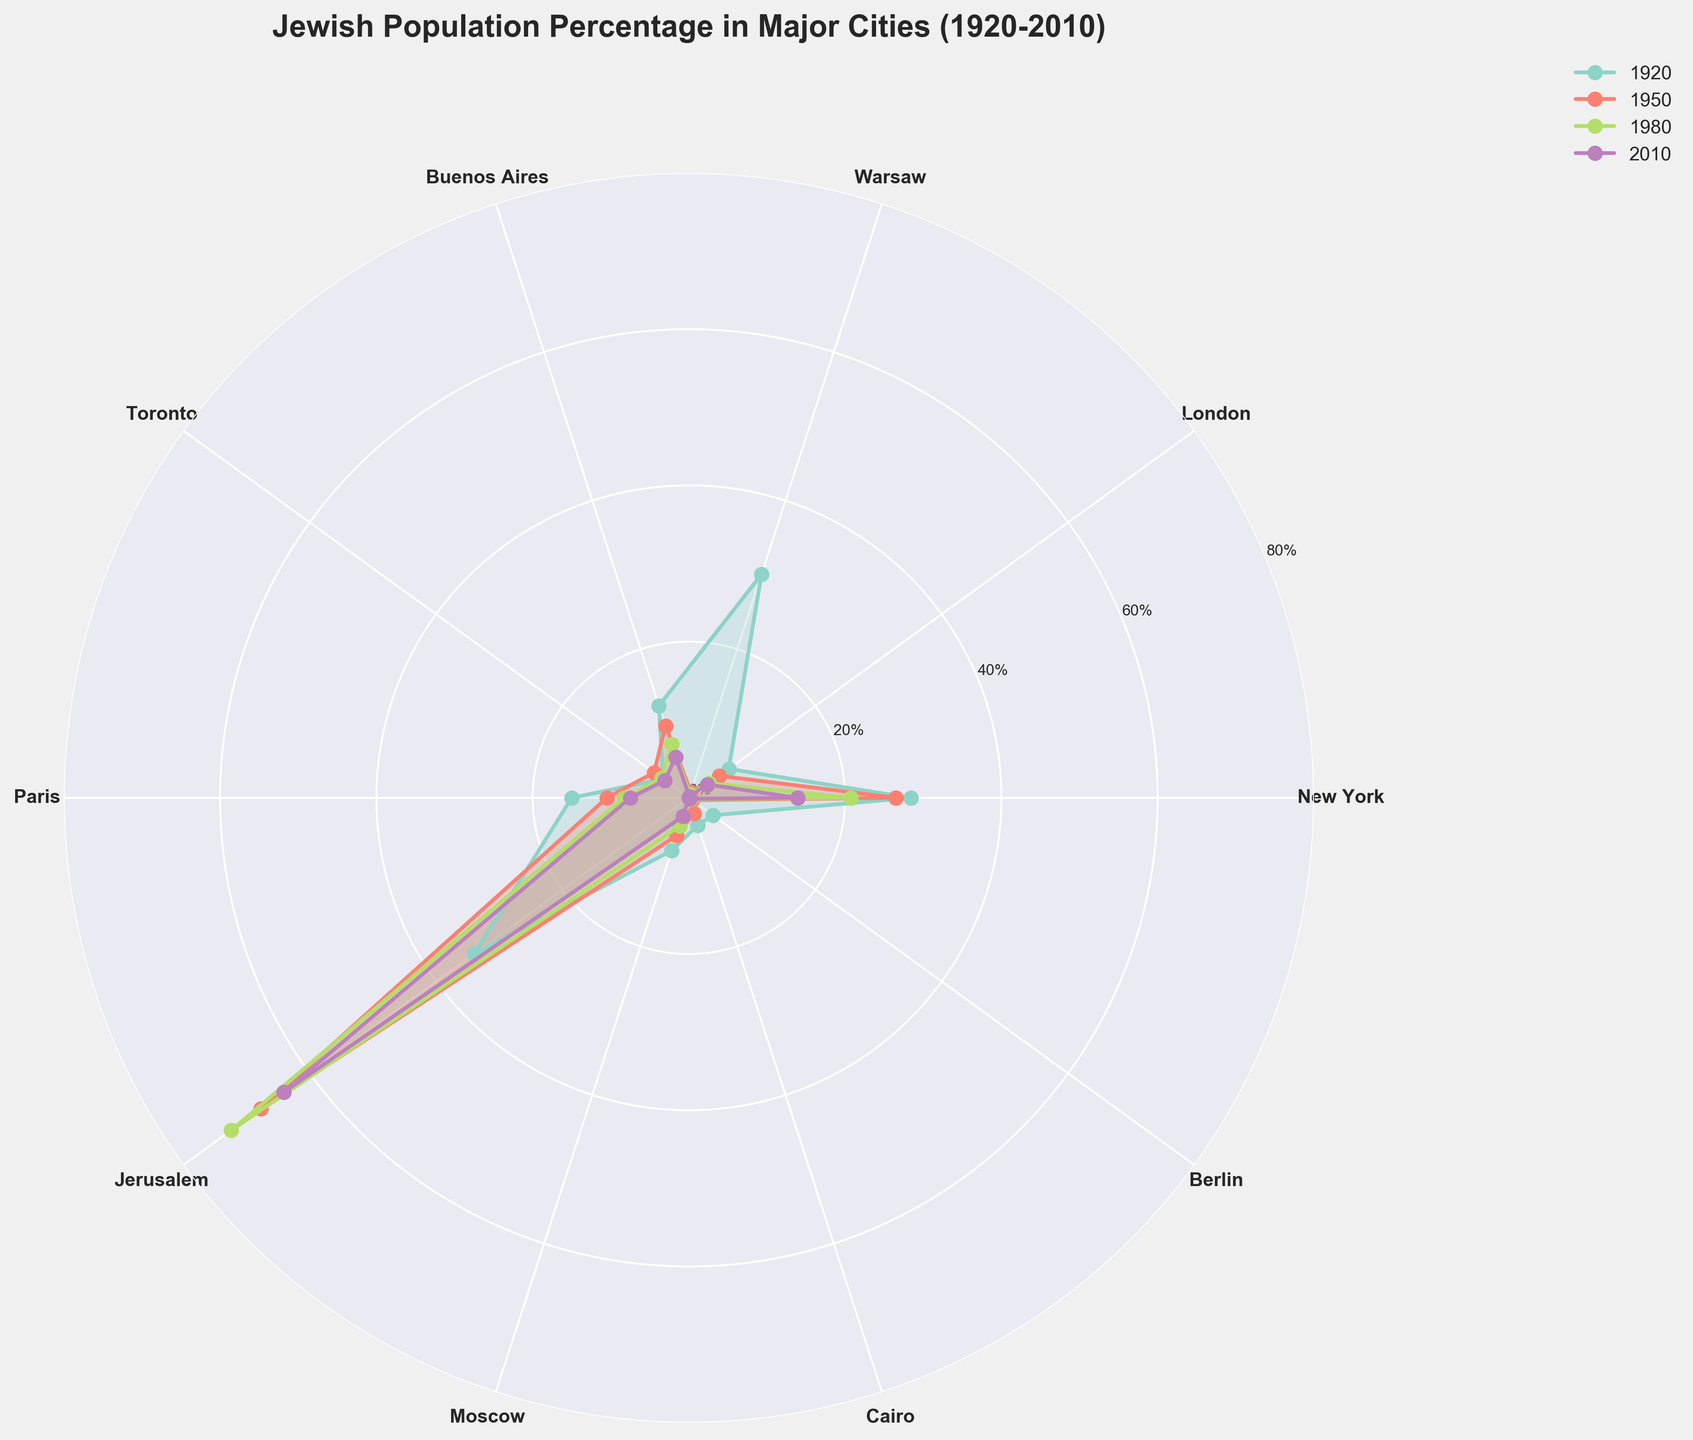What is the title of the figure? The title is usually displayed at the top center of the plot. It is in bold and larger font size compared to other text elements.
Answer: Jewish Population Percentage in Major Cities (1920-2010) How many cities are displayed in the figure? The cities are marked at each angle of the rose chart, which can be counted easily.
Answer: 10 cities What is the Jewish percentage in Warsaw in 1950? By locating the angle for Warsaw and tracing the polygon line for the 1950 color, we find that the percentage is labeled around the axis.
Answer: 0.8% Which city had the highest Jewish population percentage in 2010? By checking each city’s data point for the 2010 polygon (often the smallest due to diminishing values over time), we can identify the city with the highest value.
Answer: Jerusalem What was the trend of the Jewish population percentage in New York from 1920 to 2010? By following the New York data points across 1920, 1950, 1980, and 2010, we see a consistent decrease.
Answer: Decreasing Between Paris and Buenos Aires, which city had a higher Jewish percentage in 1950? Compare the angles corresponding to Paris and Buenos Aires on the 1950 polygon (using color codes).
Answer: Paris What was the percentage change in Jewish population in Cairo from 1920 to 2010? Subtract the Jewish percentage in Cairo in 2010 (0.0) from that in 1920 (3.7).
Answer: 3.7% Identify the decade with the most significant drop in the Jewish percentage for Warsaw. Look at the percentages for each decade and find the largest interval decline. The largest drop can be seen from 1920 to 1950 (30.1% to 0.8%).
Answer: 1920-1950 Which city had an increasing trend in the Jewish population percentage over the given years? Examine each city's trend from 1920 to 2010. Jerusalem shows an initial increase up to 1980.
Answer: Jerusalem (until 1980) Compare the Jewish population percentage of Toronto and Moscow in 1920. Which city had a higher percentage? Refer to the angles for Toronto and Moscow in 1920; compare the two values high-lighted at the intersection of the 1920 polygon with each angle.
Answer: Moscow 